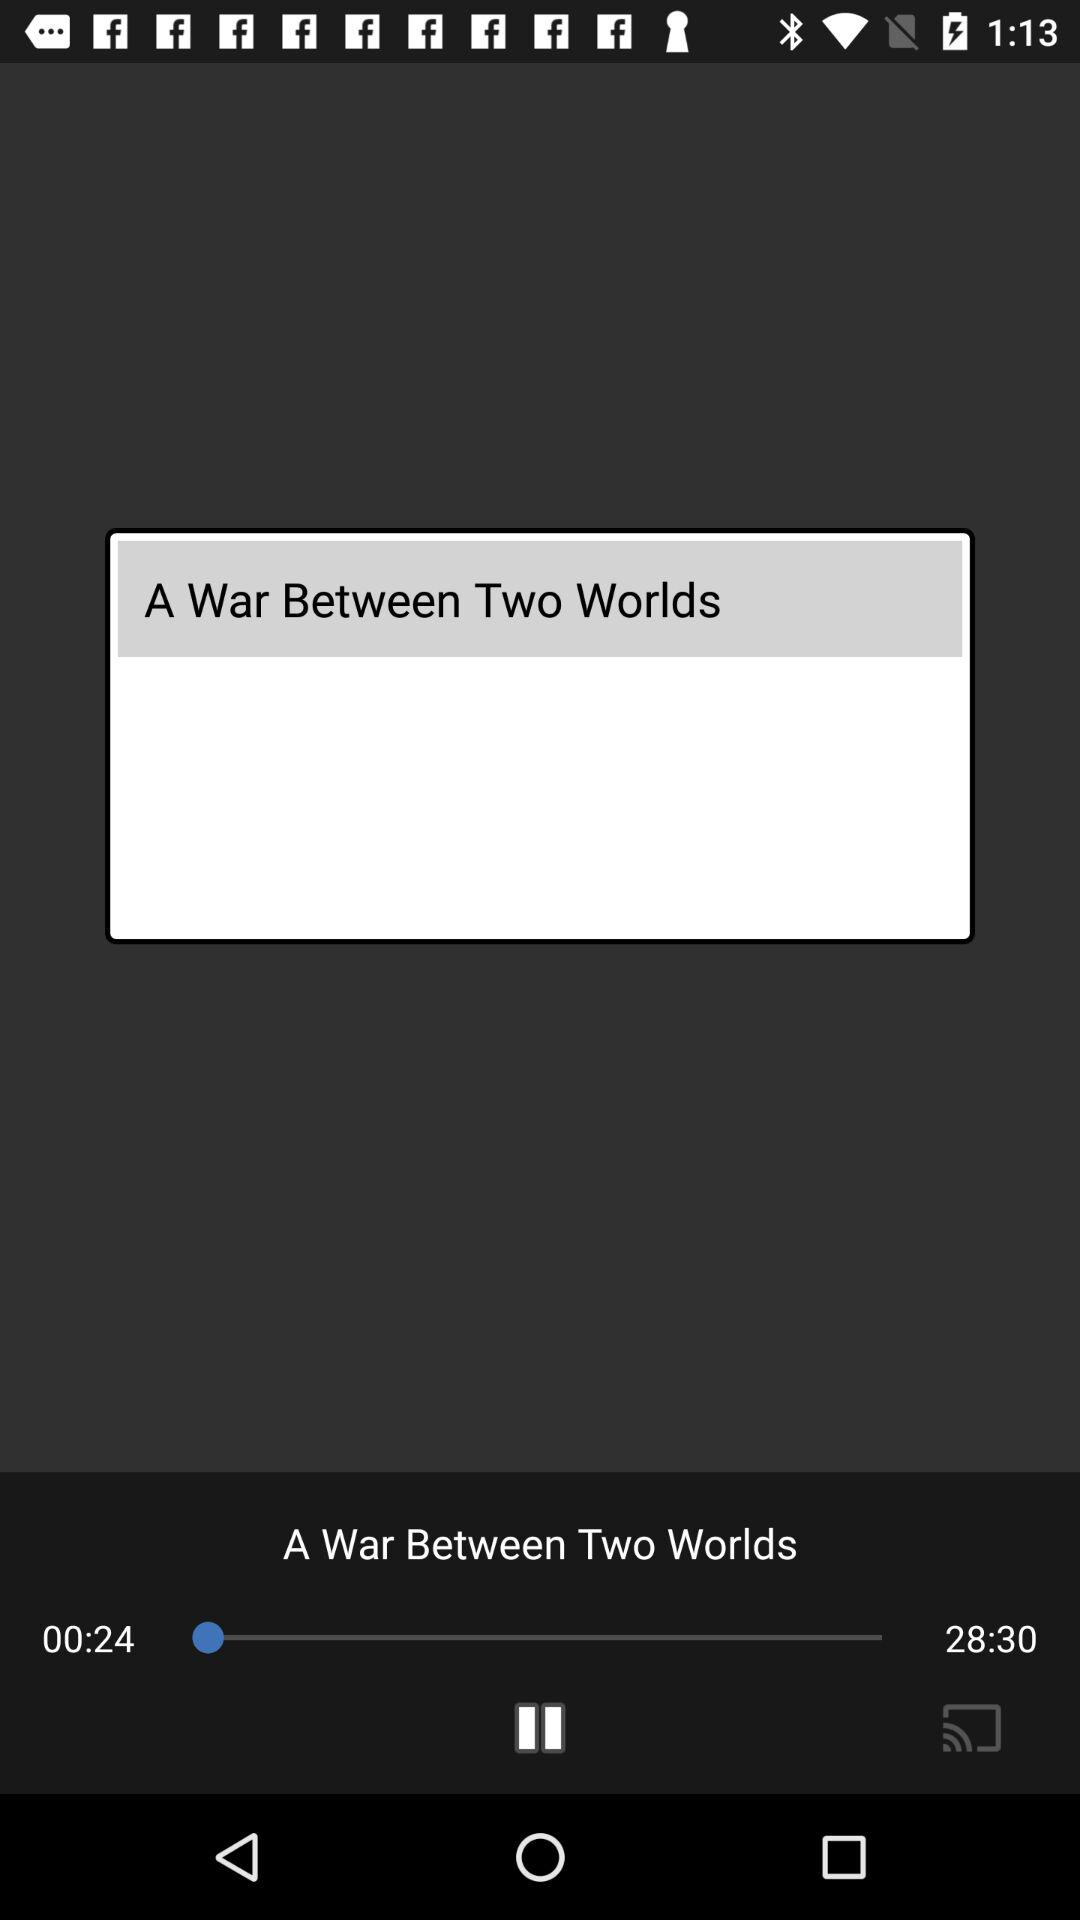What is the elapsed time of the audio? The elapsed time of the audio is 00:24. 